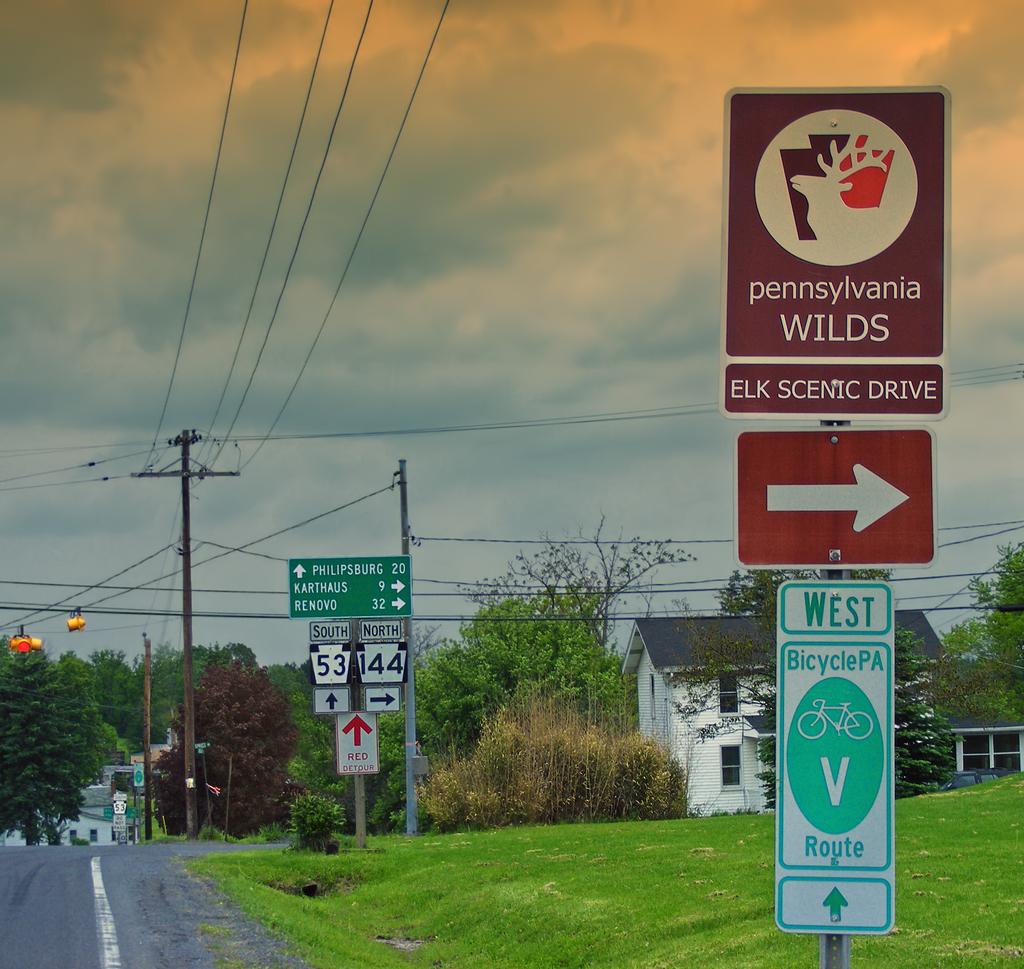What highways are up ahead?
Ensure brevity in your answer.  53, 44. What is to the right?
Make the answer very short. Elk scenic drive. 